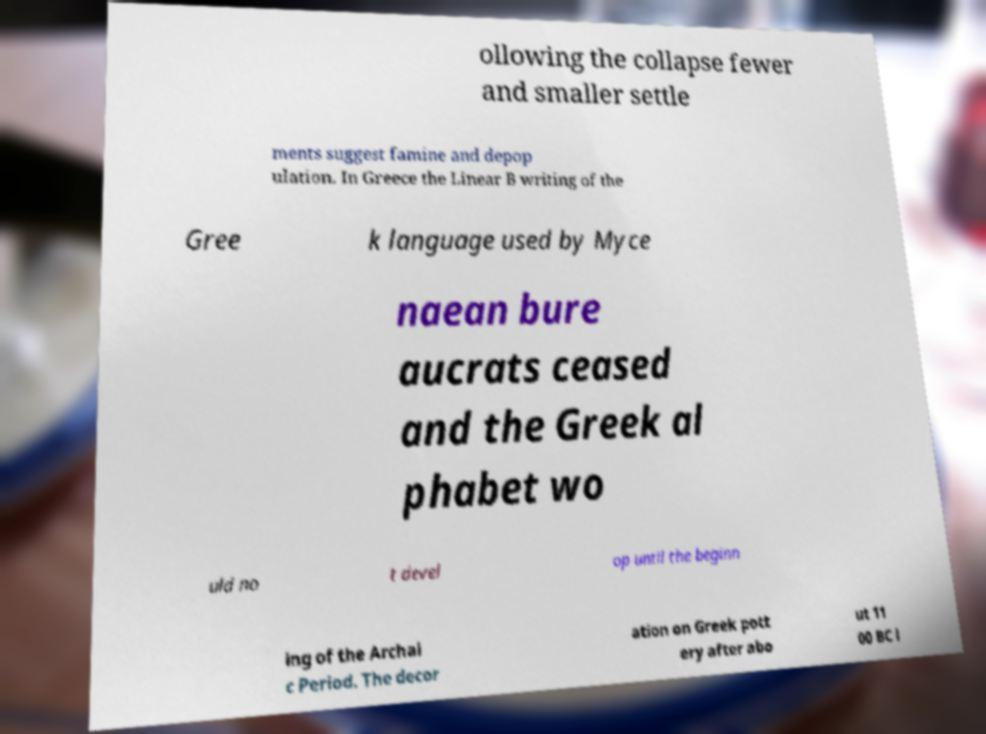Could you extract and type out the text from this image? ollowing the collapse fewer and smaller settle ments suggest famine and depop ulation. In Greece the Linear B writing of the Gree k language used by Myce naean bure aucrats ceased and the Greek al phabet wo uld no t devel op until the beginn ing of the Archai c Period. The decor ation on Greek pott ery after abo ut 11 00 BC l 